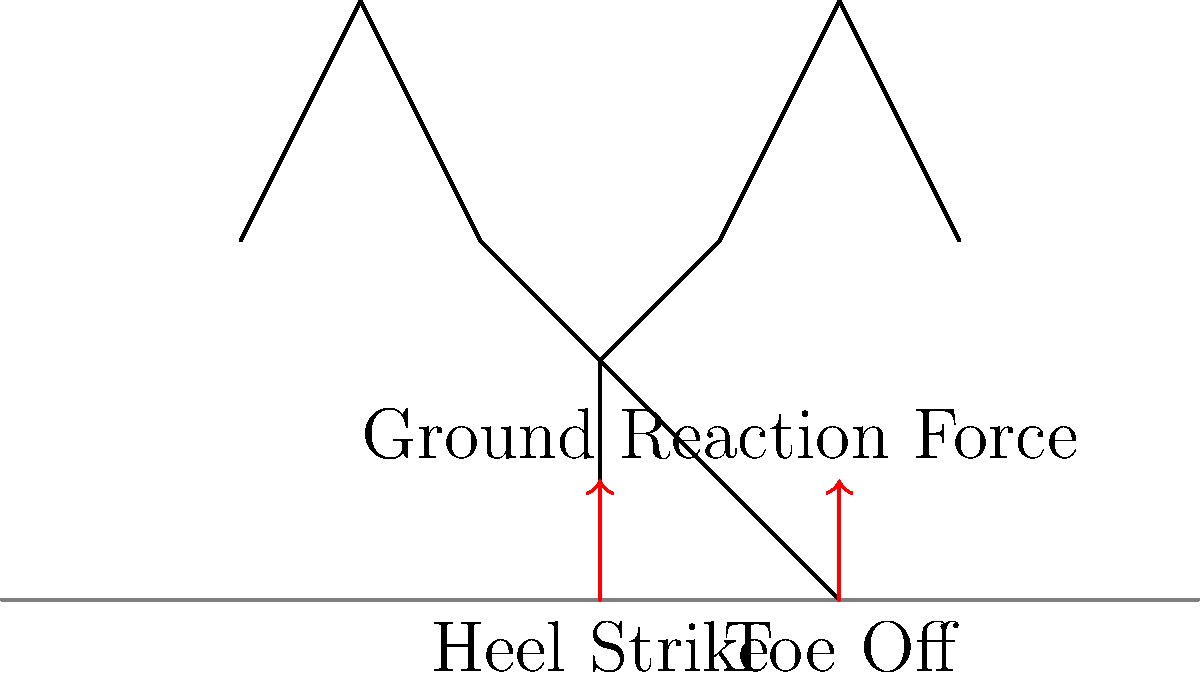In the biomechanics of running, which phase of the gait cycle typically results in the highest ground reaction force and potential joint stress? To answer this question, let's break down the gait cycle and its impact on joint health:

1. The running gait cycle consists of two main phases: stance and swing.

2. The stance phase can be further divided into:
   a) Initial contact (heel strike)
   b) Midstance
   c) Terminal stance (toe off)

3. Ground reaction force (GRF) is the force exerted by the ground on the body during impact.

4. During running:
   a) Initial contact (heel strike) typically produces the highest peak in GRF.
   b) This peak can reach 2-3 times body weight in recreational runners.
   c) Elite runners may experience forces up to 5-6 times body weight.

5. The high GRF during heel strike is due to:
   a) The sudden deceleration of the body's downward motion.
   b) The transfer of momentum from the descending body to the ground.

6. This high impact force is transmitted through the joints, particularly:
   a) Ankle
   b) Knee
   c) Hip

7. Repeated high-impact forces can lead to:
   a) Increased stress on joint structures
   b) Potential for overuse injuries, especially in the lower extremities

8. Proper running technique, appropriate footwear, and gradual training progression can help mitigate these forces and reduce injury risk.

Therefore, the heel strike phase typically results in the highest ground reaction force and potential joint stress during running.
Answer: Heel strike 